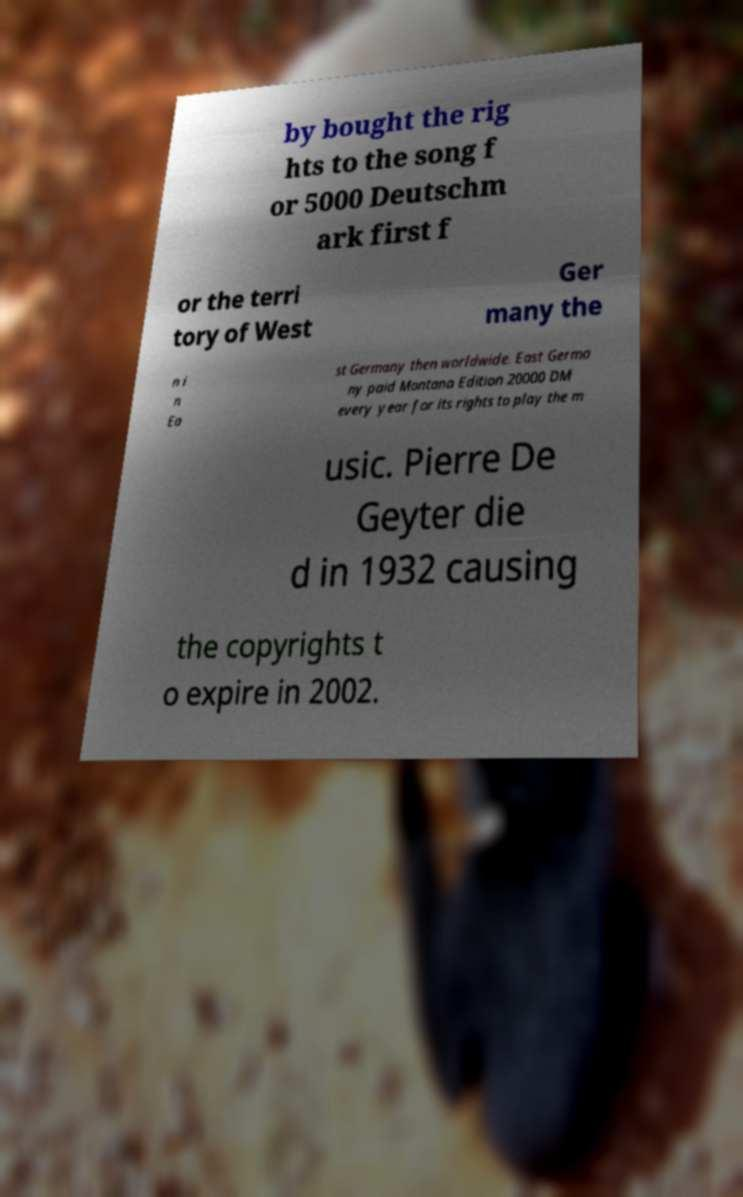Please identify and transcribe the text found in this image. by bought the rig hts to the song f or 5000 Deutschm ark first f or the terri tory of West Ger many the n i n Ea st Germany then worldwide. East Germa ny paid Montana Edition 20000 DM every year for its rights to play the m usic. Pierre De Geyter die d in 1932 causing the copyrights t o expire in 2002. 